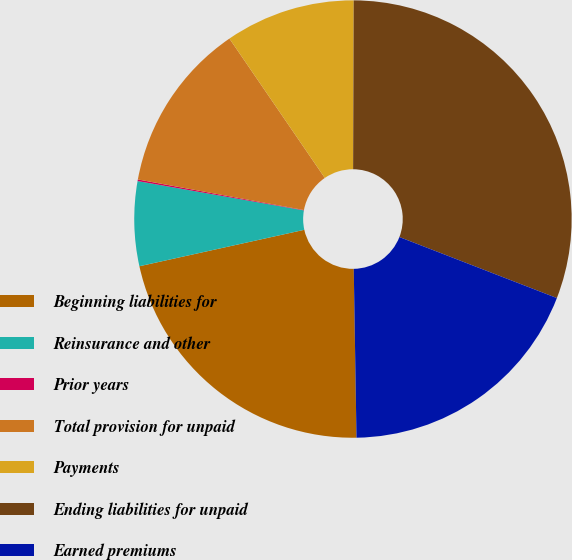Convert chart to OTSL. <chart><loc_0><loc_0><loc_500><loc_500><pie_chart><fcel>Beginning liabilities for<fcel>Reinsurance and other<fcel>Prior years<fcel>Total provision for unpaid<fcel>Payments<fcel>Ending liabilities for unpaid<fcel>Earned premiums<nl><fcel>21.8%<fcel>6.24%<fcel>0.12%<fcel>12.55%<fcel>9.61%<fcel>30.83%<fcel>18.86%<nl></chart> 